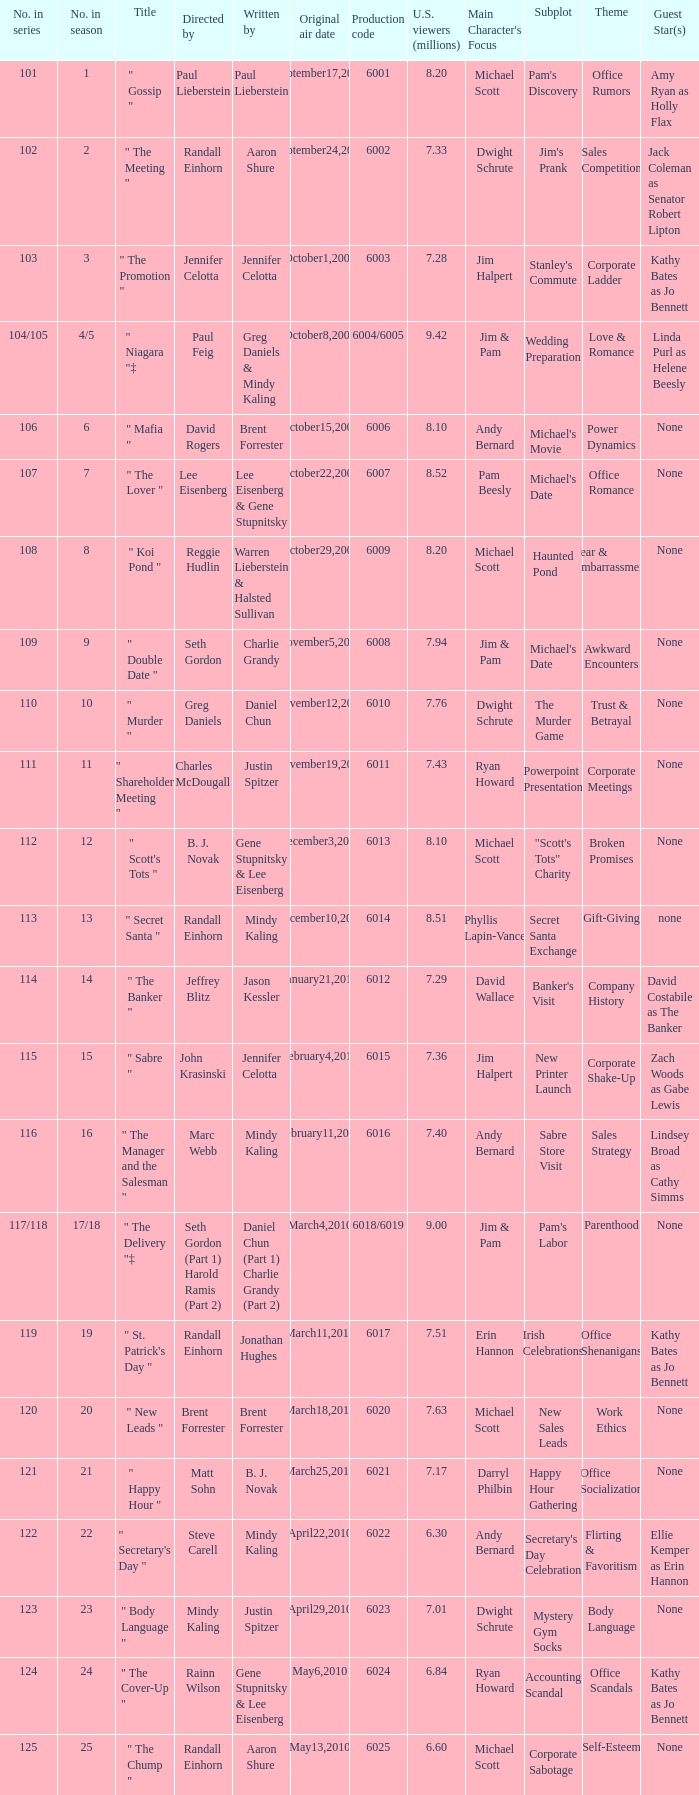Name the production code for number in season being 21 6021.0. 